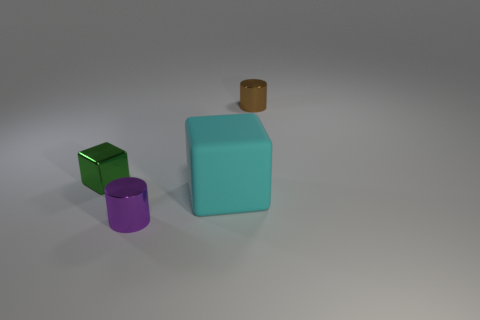Add 3 big red metal spheres. How many objects exist? 7 Add 2 blocks. How many blocks are left? 4 Add 2 blue objects. How many blue objects exist? 2 Subtract 0 gray cylinders. How many objects are left? 4 Subtract all large things. Subtract all brown cylinders. How many objects are left? 2 